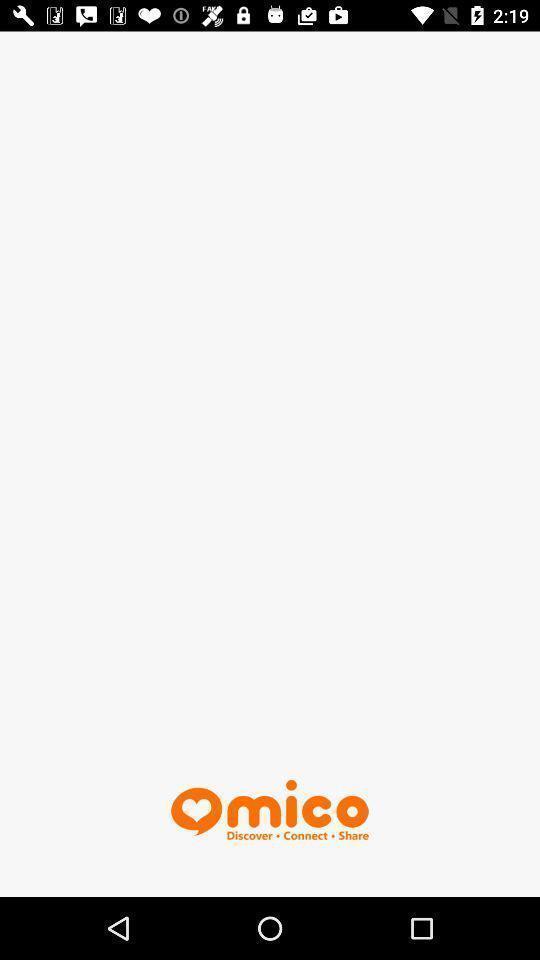Provide a description of this screenshot. Screen shows chat app page. 